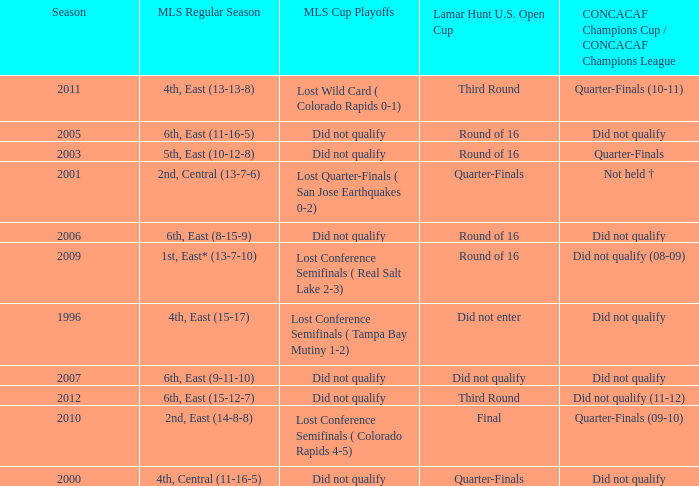What was the lamar hunt u.s. open cup when concacaf champions cup / concacaf champions league was did not qualify and mls regular season was 4th, central (11-16-5)? Quarter-Finals. 